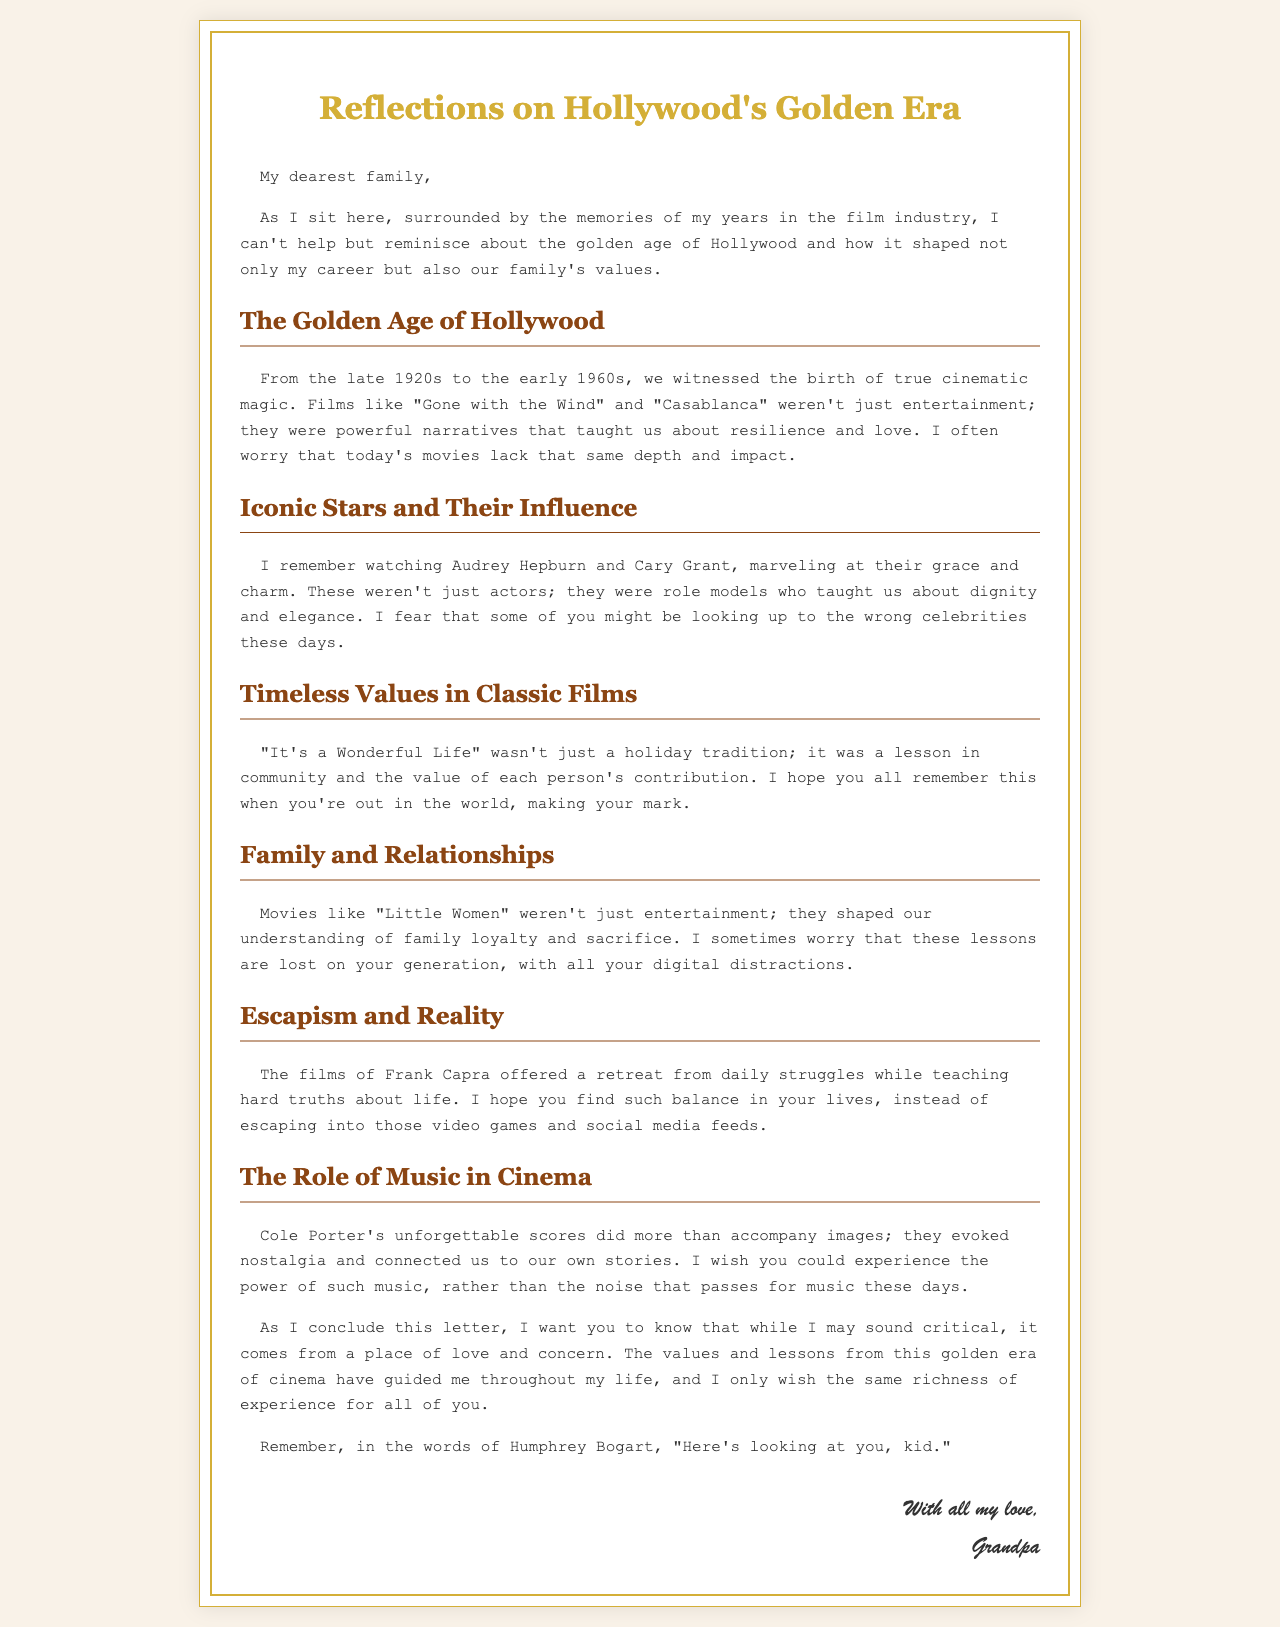what is the title of the letter? The title of the letter is provided in the document heading.
Answer: Reflections on Hollywood's Golden Era who are two iconic stars mentioned in the letter? The letter refers to two iconic stars who influenced the family's values.
Answer: Audrey Hepburn and Cary Grant what lesson does "It's a Wonderful Life" impart according to the letter? The letter discusses a specific lesson that is drawn from this classic film.
Answer: community and the value of each person's contribution what concern does the author express about today's movies? The author reflects on a specific aspect of contemporary films in comparison to classic films.
Answer: lack that same depth and impact what type of music does the author wish the family could experience? The letter highlights a specific genre of music that the author finds meaningful from classic films.
Answer: Cole Porter's unforgettable scores which film does the letter mention as shaping understanding of family loyalty? The letter specifically points to one film that emphasizes family loyalty and sacrifice.
Answer: Little Women who is quoted at the conclusion of the letter? The author cites a famous actor known for a popular quote at the end of the letter.
Answer: Humphrey Bogart what emotion does the author convey throughout the letter? The overall sentiment of the letter is reflected in the author's tone and message.
Answer: love and concern 